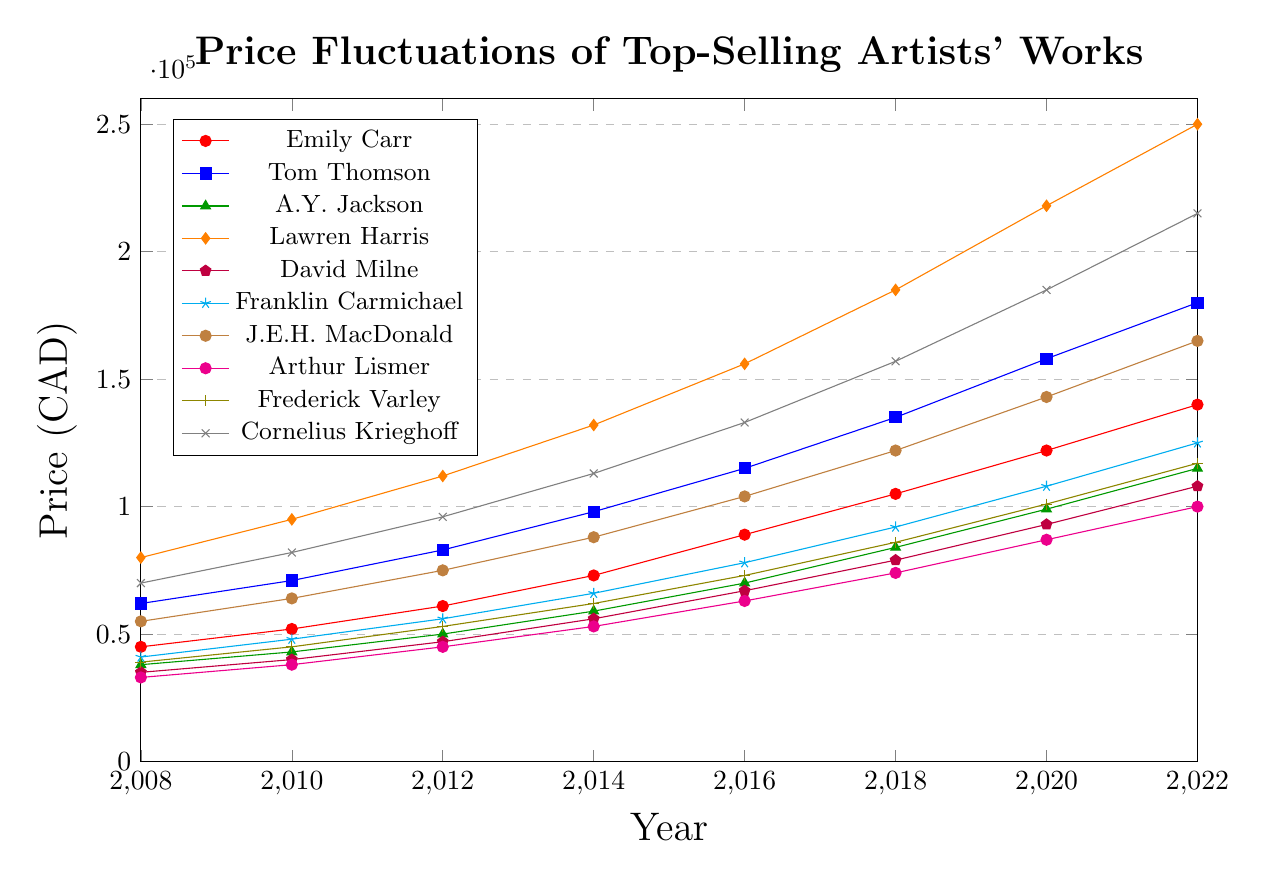What was the price of Emily Carr's work in 2012? To find the price of Emily Carr's work in 2012, refer to the Emily Carr line in the plot and look at the y-axis value corresponding to the year 2012.
Answer: 61000 Which artist had the highest price in 2022? Locate the data points for all artists in the year 2022 on the chart and find the one with the highest y-axis value.
Answer: Lawren Harris What is the average price increase per year for Tom Thomson from 2008 to 2022? Calculate the total increase from 2008 to 2022, which is 180000 - 62000 = 118000, and divide it by the number of years, which is 14.
Answer: 8428.57 Between Frederick Varley and David Milne, whose work had a higher price in 2018? Compare the y-axis values for Frederick Varley and David Milne in the year 2018. Frederick Varley's price is 86000, and David Milne's price is 79000, so Frederick Varley had a higher price.
Answer: Frederick Varley What is the total price of works by Arthur Lismer and Cornelius Krieghoff in 2016? Add the prices for Arthur Lismer (63000) and Cornelius Krieghoff (133000) in the year 2016 from the plot.
Answer: 196000 How did the price of Lawren Harris's work change between 2010 and 2016? Subtract the price in 2010 (95000) from the price in 2016 (156000) to find the change.
Answer: 61000 Which artist showed the greatest price increase between 2008 and 2022? Calculate the difference in prices between 2008 and 2022 for all artists and identify the artist with the largest difference. Lawren Harris had an increase from 80000 to 250000, which is 170000.
Answer: Lawren Harris Did any artist have a steady linear growth in their prices? Check the slope of the lines representing the artists from 2008 to 2022. A steady linear growth would show a straight-line pattern without any significant deviations.
Answer: No What is the range of prices for J.E.H. MacDonald's work from 2008 to 2022? Subtract the minimum price in 2008 (55000) from the maximum price in 2022 (165000) for J.E.H. MacDonald.
Answer: 110000 